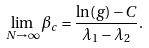Convert formula to latex. <formula><loc_0><loc_0><loc_500><loc_500>\lim _ { N \to \infty } \beta _ { c } = \frac { \ln ( g ) - C } { \lambda _ { 1 } - \lambda _ { 2 } } .</formula> 